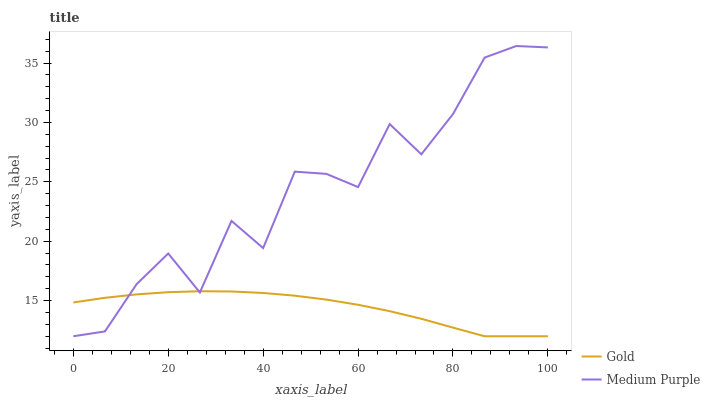Does Gold have the minimum area under the curve?
Answer yes or no. Yes. Does Medium Purple have the maximum area under the curve?
Answer yes or no. Yes. Does Gold have the maximum area under the curve?
Answer yes or no. No. Is Gold the smoothest?
Answer yes or no. Yes. Is Medium Purple the roughest?
Answer yes or no. Yes. Is Gold the roughest?
Answer yes or no. No. Does Medium Purple have the lowest value?
Answer yes or no. Yes. Does Medium Purple have the highest value?
Answer yes or no. Yes. Does Gold have the highest value?
Answer yes or no. No. Does Medium Purple intersect Gold?
Answer yes or no. Yes. Is Medium Purple less than Gold?
Answer yes or no. No. Is Medium Purple greater than Gold?
Answer yes or no. No. 